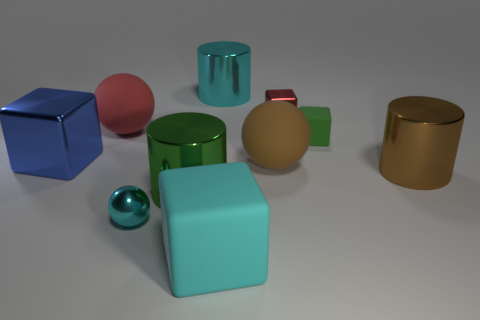There is a large cyan object right of the block that is in front of the green cylinder; what shape is it?
Make the answer very short. Cylinder. The big shiny thing that is both in front of the brown matte ball and left of the large cyan metallic cylinder has what shape?
Ensure brevity in your answer.  Cylinder. What number of objects are either big cyan blocks or matte blocks that are in front of the blue cube?
Ensure brevity in your answer.  1. There is a cyan object that is the same shape as the tiny green thing; what material is it?
Give a very brief answer. Rubber. What material is the small thing that is both in front of the small red cube and on the right side of the cyan rubber block?
Keep it short and to the point. Rubber. How many red metal things have the same shape as the brown matte object?
Your answer should be very brief. 0. There is a small shiny thing that is behind the cyan metal object in front of the red rubber thing; what color is it?
Your response must be concise. Red. Are there an equal number of brown things that are in front of the cyan ball and large green matte spheres?
Offer a very short reply. Yes. Is there a brown matte ball of the same size as the cyan rubber thing?
Offer a terse response. Yes. There is a brown matte sphere; is it the same size as the cyan metallic thing on the left side of the cyan block?
Provide a short and direct response. No. 